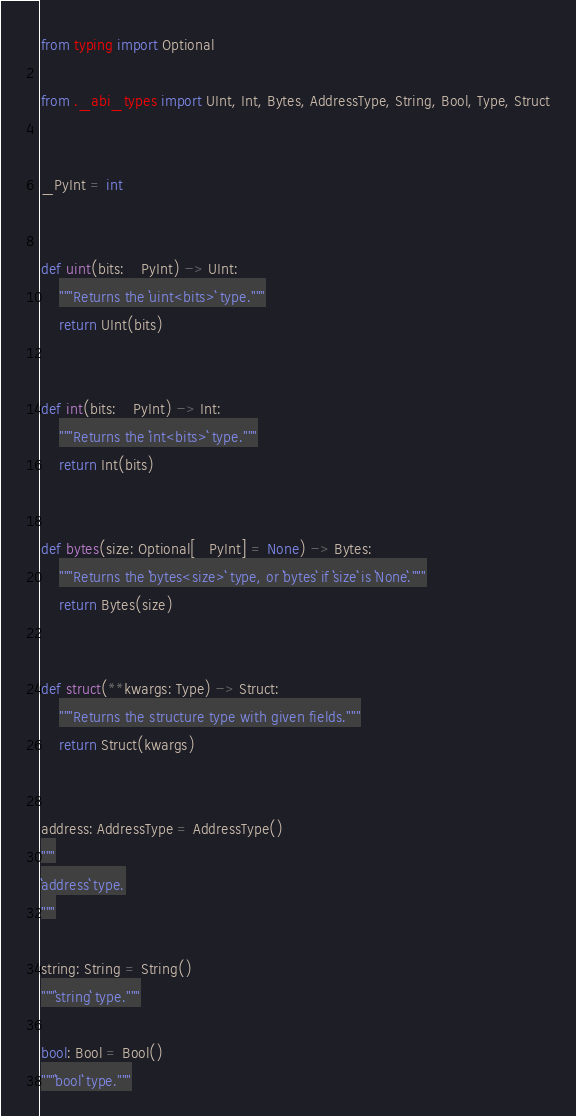<code> <loc_0><loc_0><loc_500><loc_500><_Python_>from typing import Optional

from ._abi_types import UInt, Int, Bytes, AddressType, String, Bool, Type, Struct


_PyInt = int


def uint(bits: _PyInt) -> UInt:
    """Returns the ``uint<bits>`` type."""
    return UInt(bits)


def int(bits: _PyInt) -> Int:
    """Returns the ``int<bits>`` type."""
    return Int(bits)


def bytes(size: Optional[_PyInt] = None) -> Bytes:
    """Returns the ``bytes<size>`` type, or ``bytes`` if ``size`` is ``None``."""
    return Bytes(size)


def struct(**kwargs: Type) -> Struct:
    """Returns the structure type with given fields."""
    return Struct(kwargs)


address: AddressType = AddressType()
"""
``address`` type.
"""

string: String = String()
"""``string`` type."""

bool: Bool = Bool()
"""``bool`` type."""
</code> 